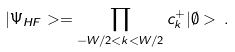<formula> <loc_0><loc_0><loc_500><loc_500>| \Psi _ { H F } > = \prod _ { - W / 2 < k < W / 2 } c _ { k } ^ { + } | \emptyset > \, .</formula> 